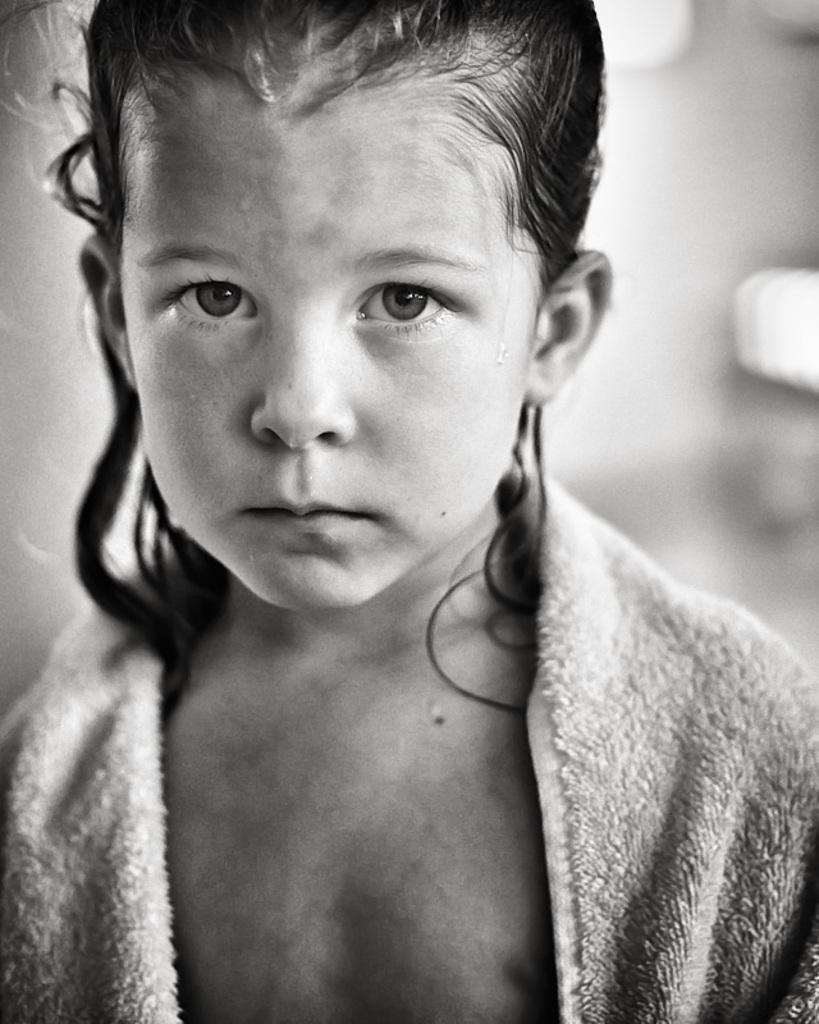Please provide a concise description of this image. This is a black and white image. In the middle of this image, there is a girl having partially covered her body with a towel. And the background is blurred. 